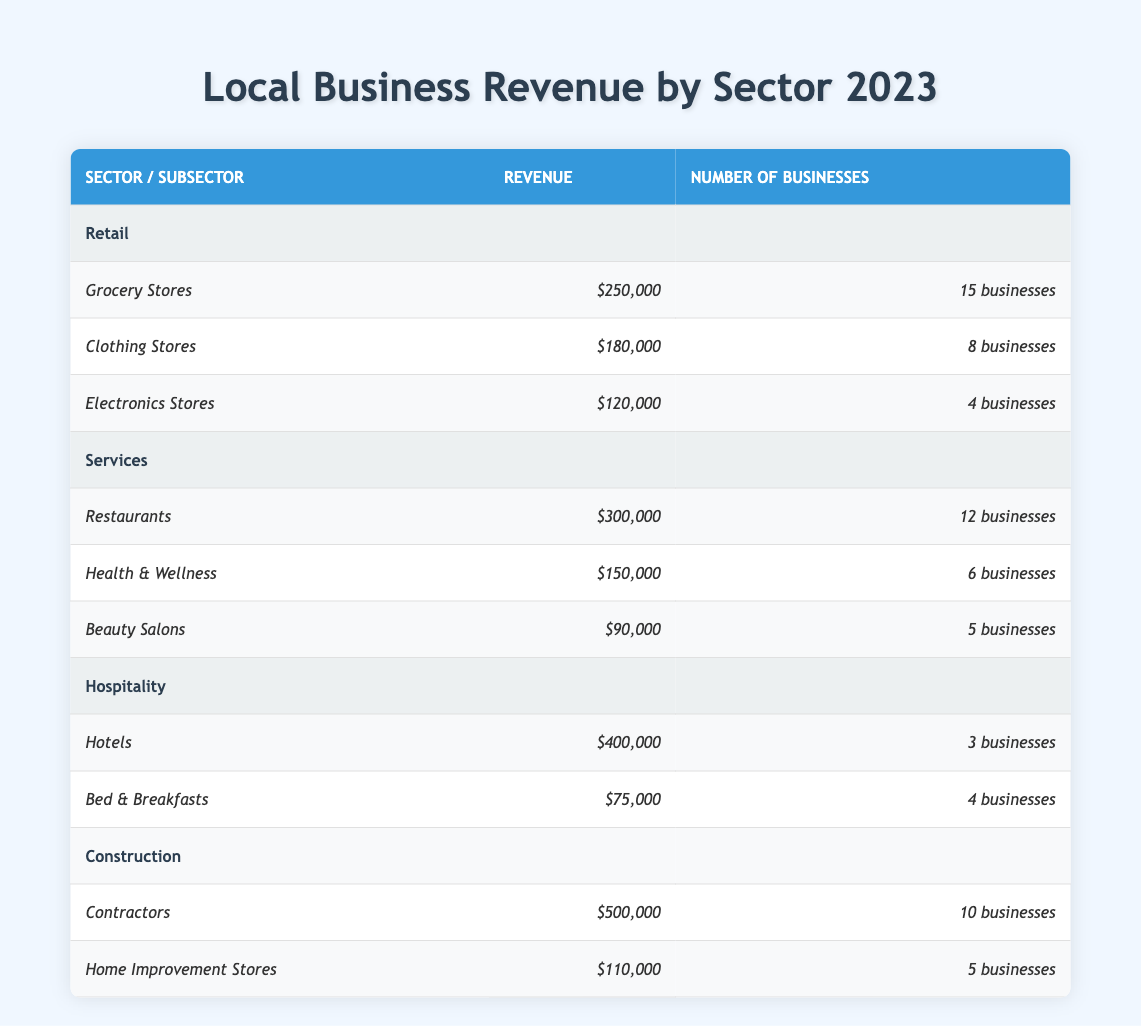What is the total revenue generated by the Retail sector? The Retail sector includes Grocery Stores with 250,000, Clothing Stores with 180,000, and Electronics Stores with 120,000. The total is calculated as 250,000 + 180,000 + 120,000 = 550,000.
Answer: 550,000 How many businesses are in the Services sector? The Services sector has Restaurants with 12 businesses, Health & Wellness with 6, and Beauty Salons with 5. Summing these gives 12 + 6 + 5 = 23 businesses in total.
Answer: 23 Which sector has the highest revenue? Looking at the sectors, Construction has revenue of 500,000, Services has 300,000, Retail has 550,000, and Hospitality has 400,000. Therefore, Retail, with 550,000, has the highest revenue.
Answer: Retail Is the total revenue from Hotels greater than 200,000? The revenue for Hotels is 400,000. Since 400,000 is greater than 200,000, the answer is yes.
Answer: Yes What is the average revenue of the businesses in the Hospitality sector? The Hospitality sector includes Hotels with revenue of 400,000 and Bed & Breakfasts with revenue of 75,000. The total revenue is 400,000 + 75,000 = 475,000. Since there are 2 businesses, the average revenue is 475,000 / 2 = 237,500.
Answer: 237,500 How many more businesses are there in the Retail sector than in the Hospitality sector? The Retail sector has Grocery Stores (15), Clothing Stores (8), and Electronics Stores (4), totaling 27 businesses. The Hospitality sector has Hotels (3) and Bed & Breakfasts (4), totaling 7 businesses. The difference is 27 - 7 = 20 more businesses.
Answer: 20 Does the Beauty Salons revenue exceed the average revenue from the total number of businesses in the Services sector? Total revenue for the Services sector is 300,000 + 150,000 + 90,000 = 540,000 and there are 12 + 6 + 5 = 23 businesses. The average is 540,000 / 23 = 23,478. Beauty Salons revenue is 90,000, which is greater than the average, so the result is no.
Answer: No What is the combined revenue of Grocery Stores and Restaurants? Grocery Stores revenue is 250,000 and Restaurants revenue is 300,000. Combining them gives a total of 250,000 + 300,000 = 550,000.
Answer: 550,000 How does the number of businesses in Contractors compare to that in Health & Wellness? Contractors have 10 businesses, while Health & Wellness has 6. Since 10 is greater than 6, Contractors have more businesses.
Answer: Contractors have more businesses 